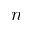<formula> <loc_0><loc_0><loc_500><loc_500>n</formula> 